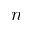<formula> <loc_0><loc_0><loc_500><loc_500>n</formula> 